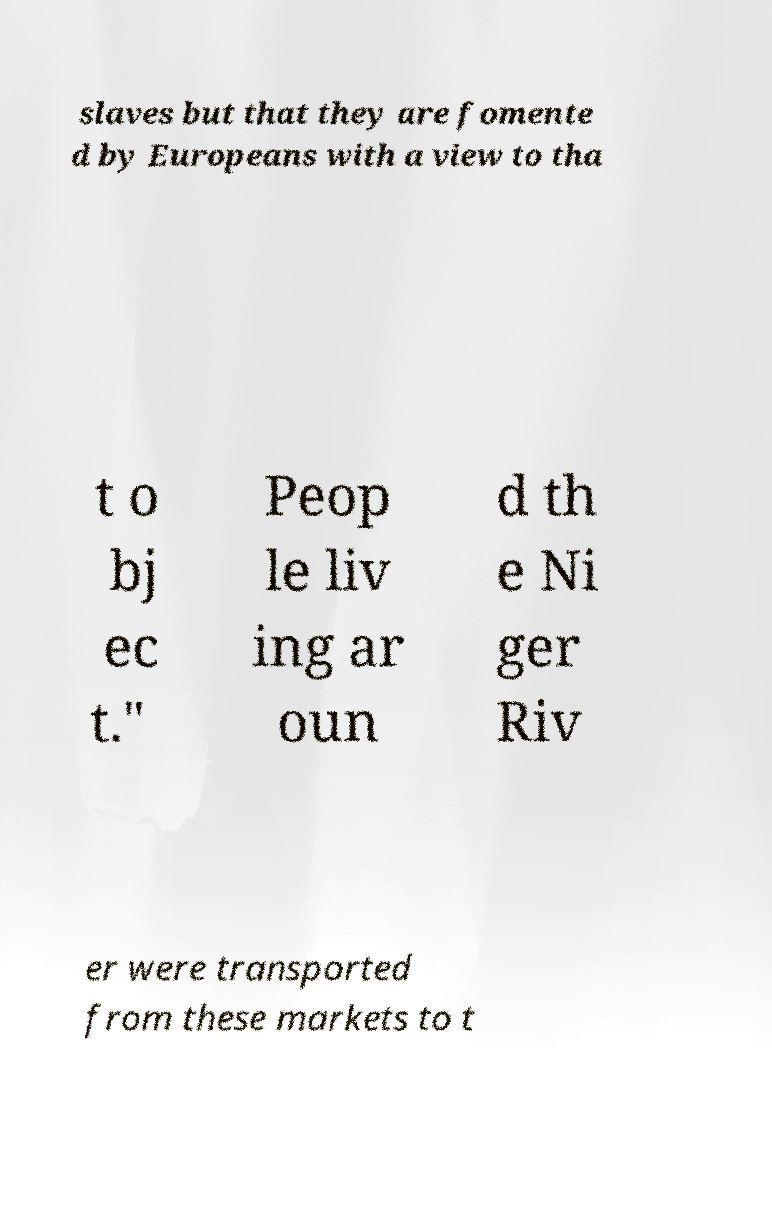Could you assist in decoding the text presented in this image and type it out clearly? slaves but that they are fomente d by Europeans with a view to tha t o bj ec t." Peop le liv ing ar oun d th e Ni ger Riv er were transported from these markets to t 